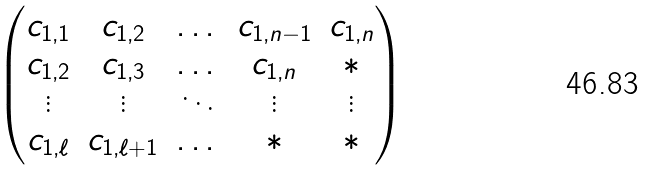Convert formula to latex. <formula><loc_0><loc_0><loc_500><loc_500>\begin{pmatrix} c _ { 1 , 1 } & c _ { 1 , 2 } & \dots & c _ { 1 , n - 1 } & c _ { 1 , n } \\ c _ { 1 , 2 } & c _ { 1 , 3 } & \dots & c _ { 1 , n } & * \\ \vdots & \vdots & \ddots & \vdots & \vdots \\ c _ { 1 , \ell } & c _ { 1 , \ell + 1 } & \dots & * & * \end{pmatrix}</formula> 